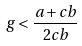Convert formula to latex. <formula><loc_0><loc_0><loc_500><loc_500>g < \frac { a + c b } { 2 c b }</formula> 